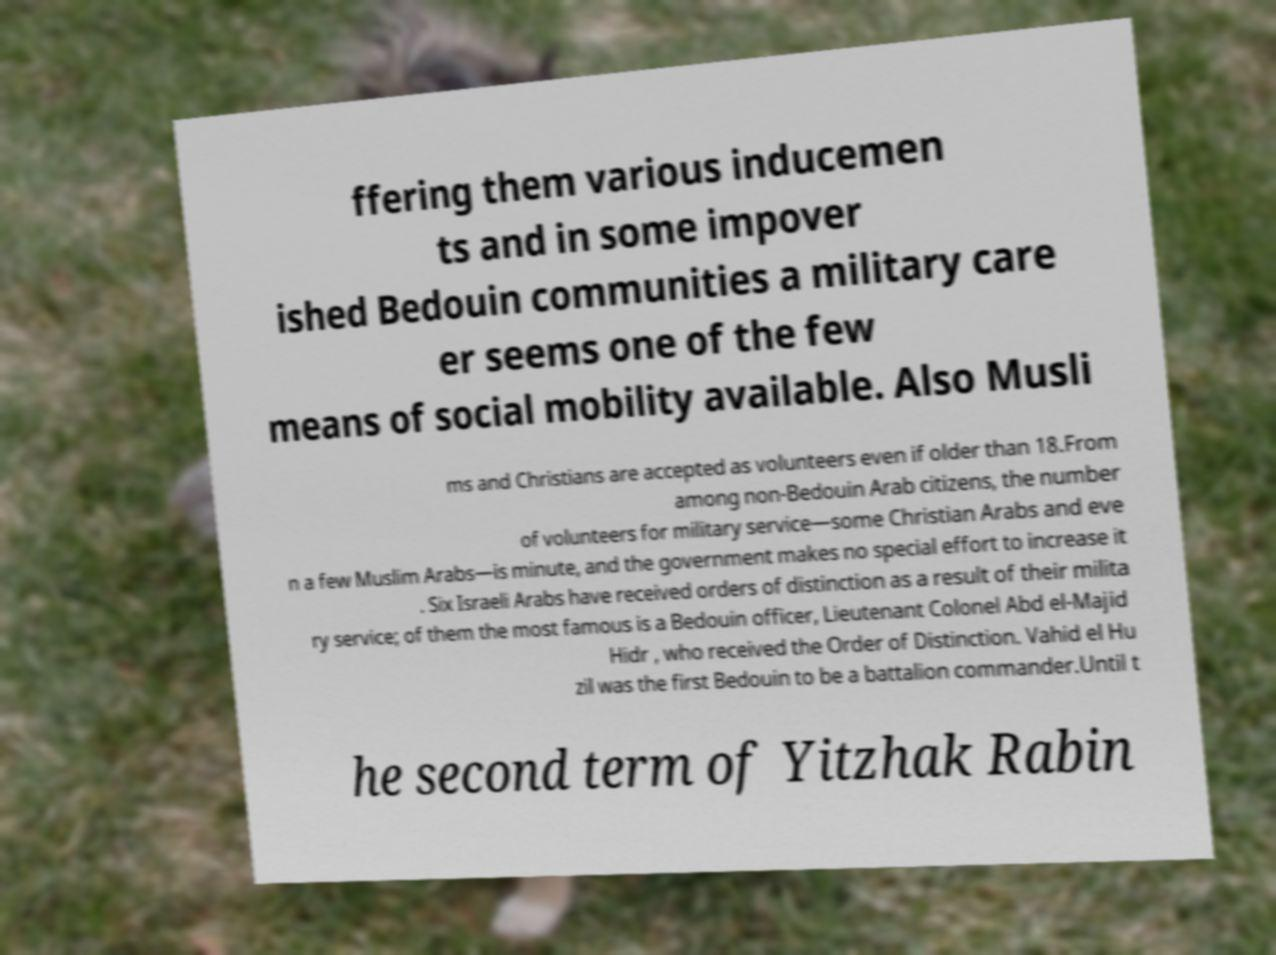Could you assist in decoding the text presented in this image and type it out clearly? ffering them various inducemen ts and in some impover ished Bedouin communities a military care er seems one of the few means of social mobility available. Also Musli ms and Christians are accepted as volunteers even if older than 18.From among non-Bedouin Arab citizens, the number of volunteers for military service—some Christian Arabs and eve n a few Muslim Arabs—is minute, and the government makes no special effort to increase it . Six Israeli Arabs have received orders of distinction as a result of their milita ry service; of them the most famous is a Bedouin officer, Lieutenant Colonel Abd el-Majid Hidr , who received the Order of Distinction. Vahid el Hu zil was the first Bedouin to be a battalion commander.Until t he second term of Yitzhak Rabin 